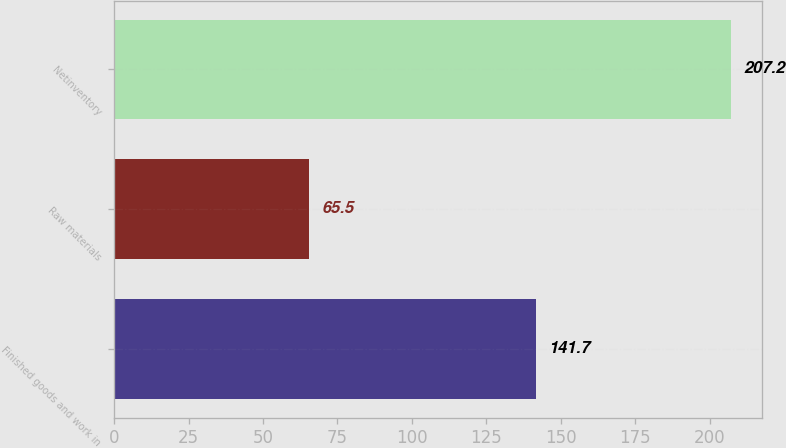Convert chart to OTSL. <chart><loc_0><loc_0><loc_500><loc_500><bar_chart><fcel>Finished goods and work in<fcel>Raw materials<fcel>Netinventory<nl><fcel>141.7<fcel>65.5<fcel>207.2<nl></chart> 